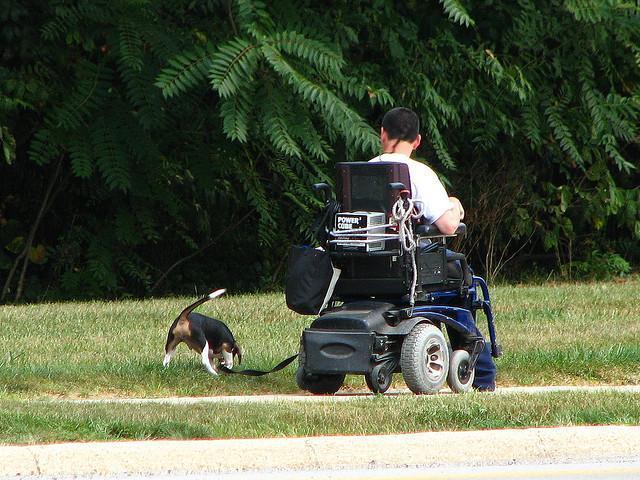What is the purpose of the power cube on the back of the wheelchair?
Choose the right answer and clarify with the format: 'Answer: answer
Rationale: rationale.'
Options: Storage, for aesthetics, for weight, move it. Answer: move it.
Rationale: Scooters require a mobile power source. 